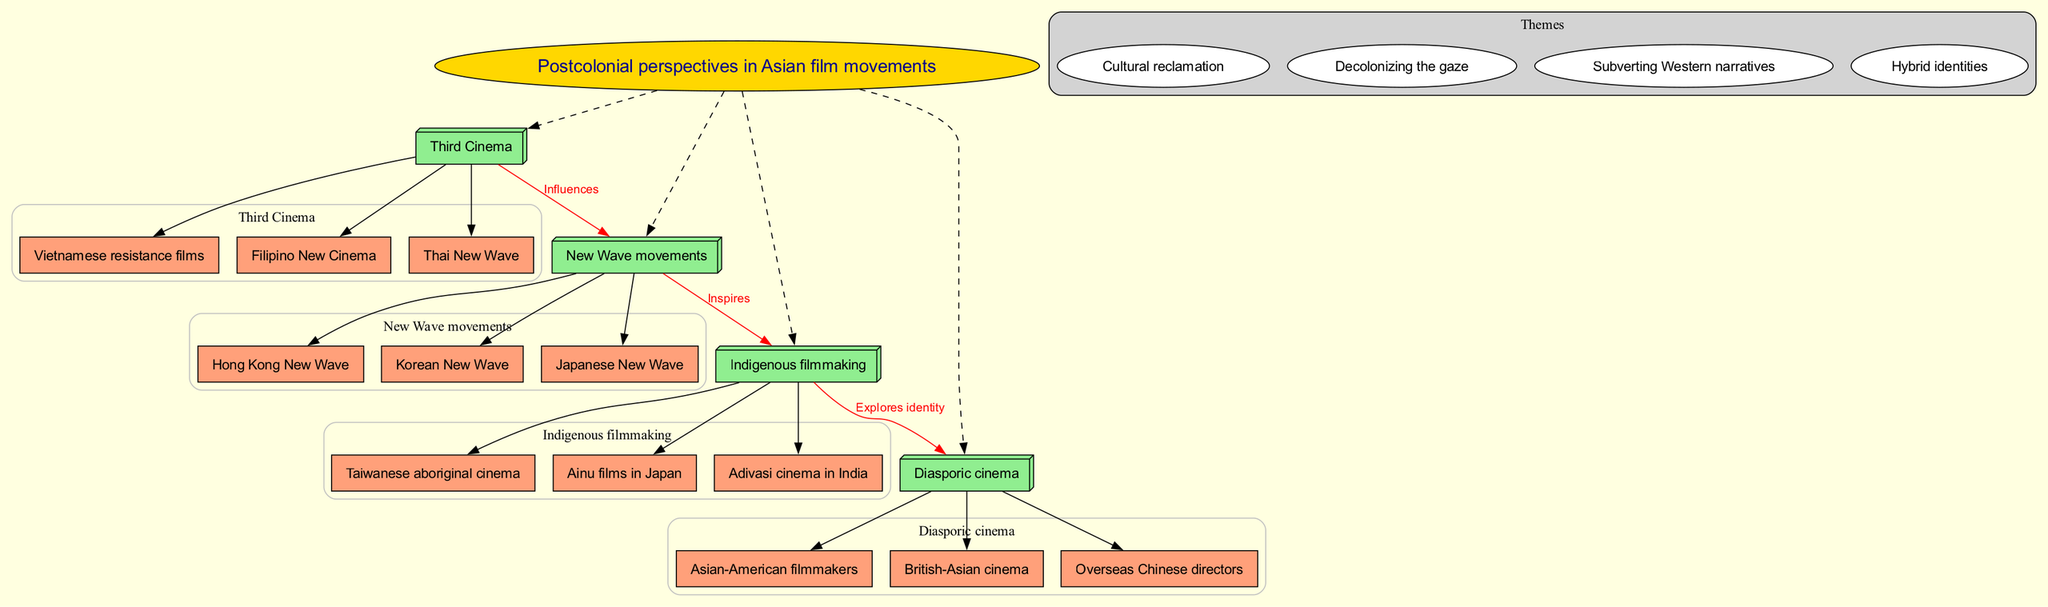What is the central concept of the diagram? The central concept is indicated by the large ellipse at the center of the diagram. It's labeled as "Postcolonial perspectives in Asian film movements."
Answer: Postcolonial perspectives in Asian film movements How many main nodes are connected to the central concept? The main nodes are listed directly under the central concept. There are four main nodes in total: "Third Cinema," "New Wave movements," "Indigenous filmmaking," and "Diasporic cinema."
Answer: 4 What is one theme represented in the diagram? The themes are clustered together and one of the themes is labeled "Cultural reclamation." There are multiple themes listed, but any of them would be a valid answer.
Answer: Cultural reclamation Which sub-node is part of "Third Cinema"? The sub-nodes of "Third Cinema" are clearly outlined and one of the sub-nodes is "Filipino New Cinema." This can be found by looking at the cluster under "Third Cinema."
Answer: Filipino New Cinema What connection describes the relationship between "Third Cinema" and "New Wave movements"? The relationship is indicated by a red edge, labeled "Influences," that connects "Third Cinema" directly to "New Wave movements."
Answer: Influences Which main node inspires "Indigenous filmmaking"? The connection between "New Wave movements" and "Indigenous filmmaking" is stated on a red edge, labeled "Inspires." This means "New Wave movements" is the main node that inspires "Indigenous filmmaking."
Answer: New Wave movements How many sub-nodes are listed under "Indigenous filmmaking"? To find this, refer to the cluster associated with "Indigenous filmmaking." There are three sub-nodes connected to it: "Taiwanese aboriginal cinema," "Ainu films in Japan," and "Adivasi cinema in India." This totals three sub-nodes.
Answer: 3 What is the nature of the relationship between "Indigenous filmmaking" and "Diasporic cinema"? The relationship is depicted with a red edge and is labeled "Explores identity," indicating how these two concepts interact in the context of the diagram.
Answer: Explores identity Which sub-node is part of the "Korean New Wave"? The diagram lists sub-nodes under "New Wave movements." Among these, one specific sub-node connected to this category is "Korean New Wave."
Answer: Korean New Wave 